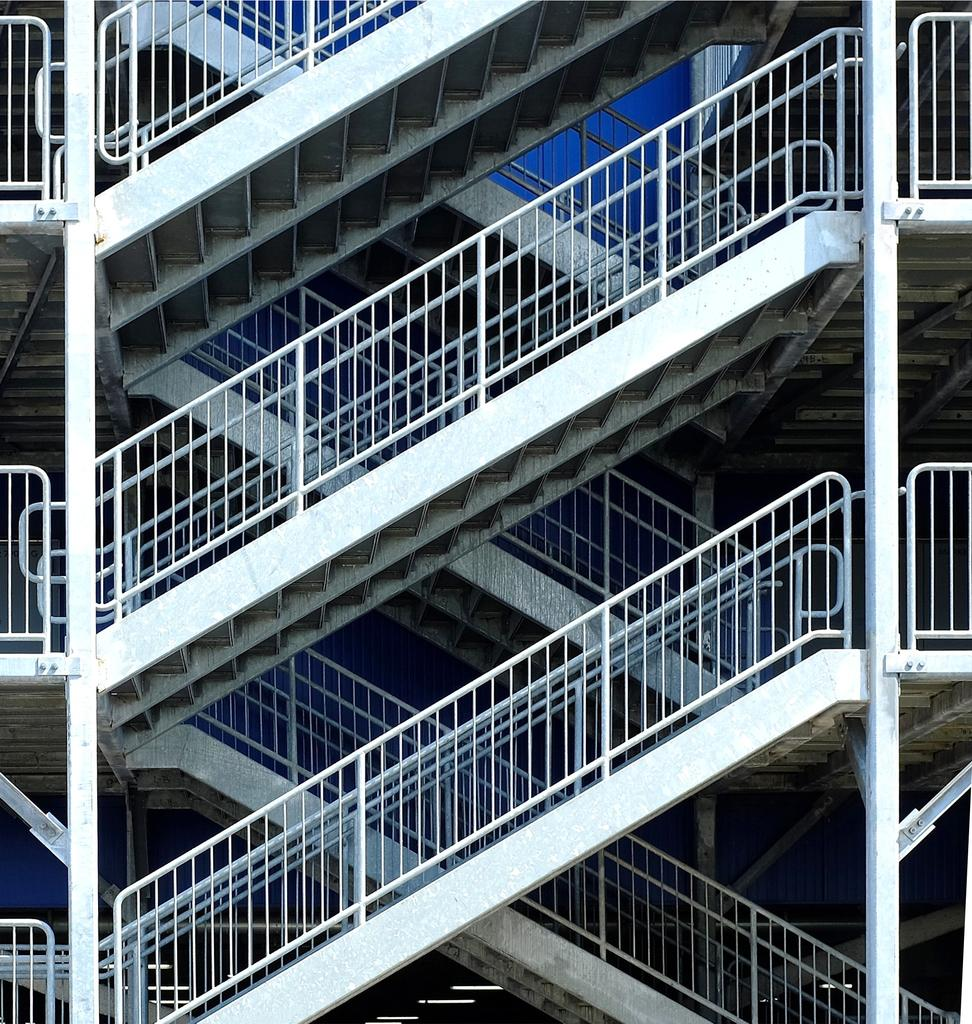What type of structure can be seen in the image? There are stairs in the image. Are there any safety features associated with the stairs? Yes, there are railings in the image. What type of drain is visible at the bottom of the stairs in the image? There is no drain visible at the bottom of the stairs in the image. 